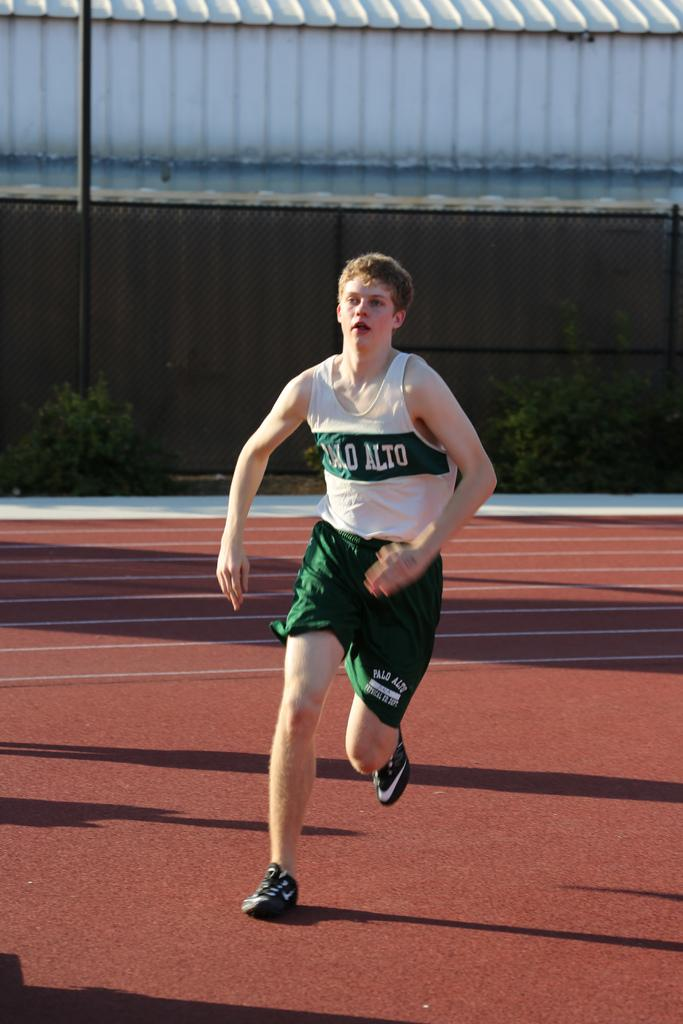<image>
Provide a brief description of the given image. A man in a green and white Palo Alto track uniform is running. 